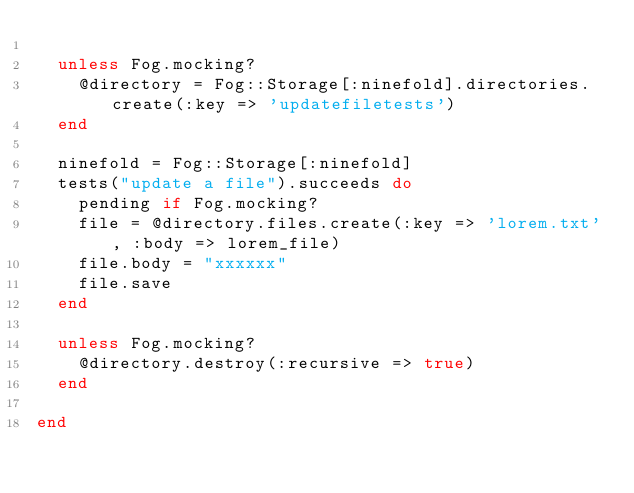<code> <loc_0><loc_0><loc_500><loc_500><_Ruby_>
  unless Fog.mocking?
    @directory = Fog::Storage[:ninefold].directories.create(:key => 'updatefiletests')
  end

  ninefold = Fog::Storage[:ninefold]
  tests("update a file").succeeds do
    pending if Fog.mocking?
    file = @directory.files.create(:key => 'lorem.txt', :body => lorem_file)
    file.body = "xxxxxx"
    file.save
  end

  unless Fog.mocking?
    @directory.destroy(:recursive => true)
  end

end</code> 